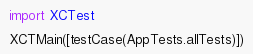Convert code to text. <code><loc_0><loc_0><loc_500><loc_500><_Swift_>import XCTest

XCTMain([testCase(AppTests.allTests)])
</code> 